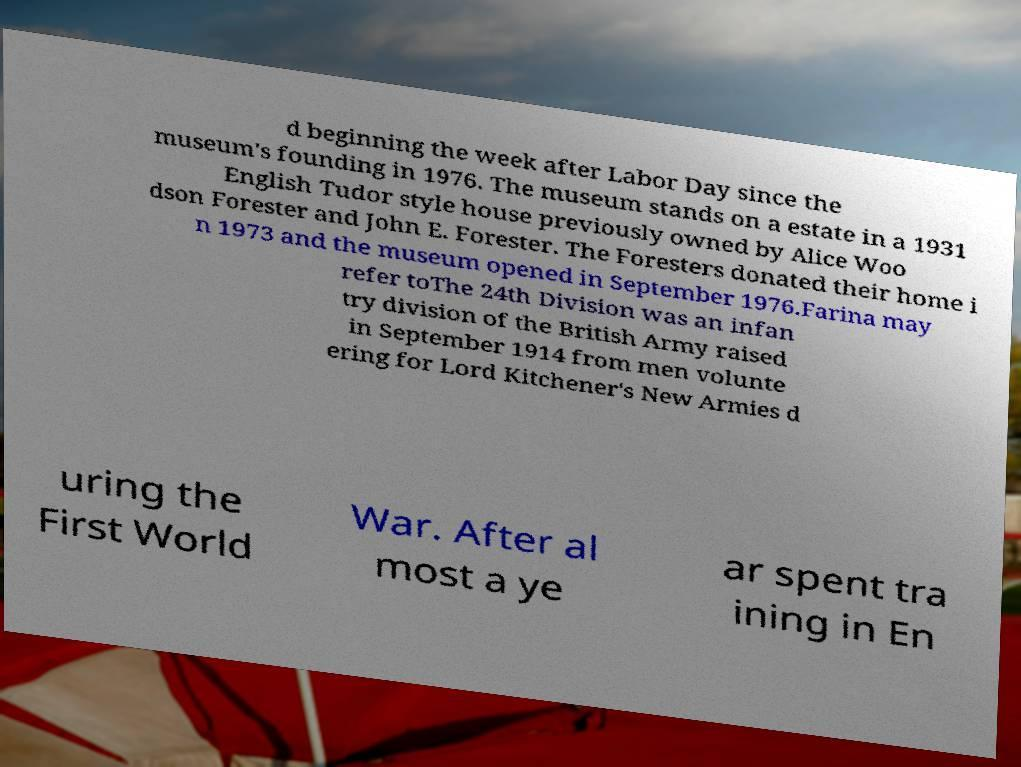Can you accurately transcribe the text from the provided image for me? d beginning the week after Labor Day since the museum's founding in 1976. The museum stands on a estate in a 1931 English Tudor style house previously owned by Alice Woo dson Forester and John E. Forester. The Foresters donated their home i n 1973 and the museum opened in September 1976.Farina may refer toThe 24th Division was an infan try division of the British Army raised in September 1914 from men volunte ering for Lord Kitchener's New Armies d uring the First World War. After al most a ye ar spent tra ining in En 